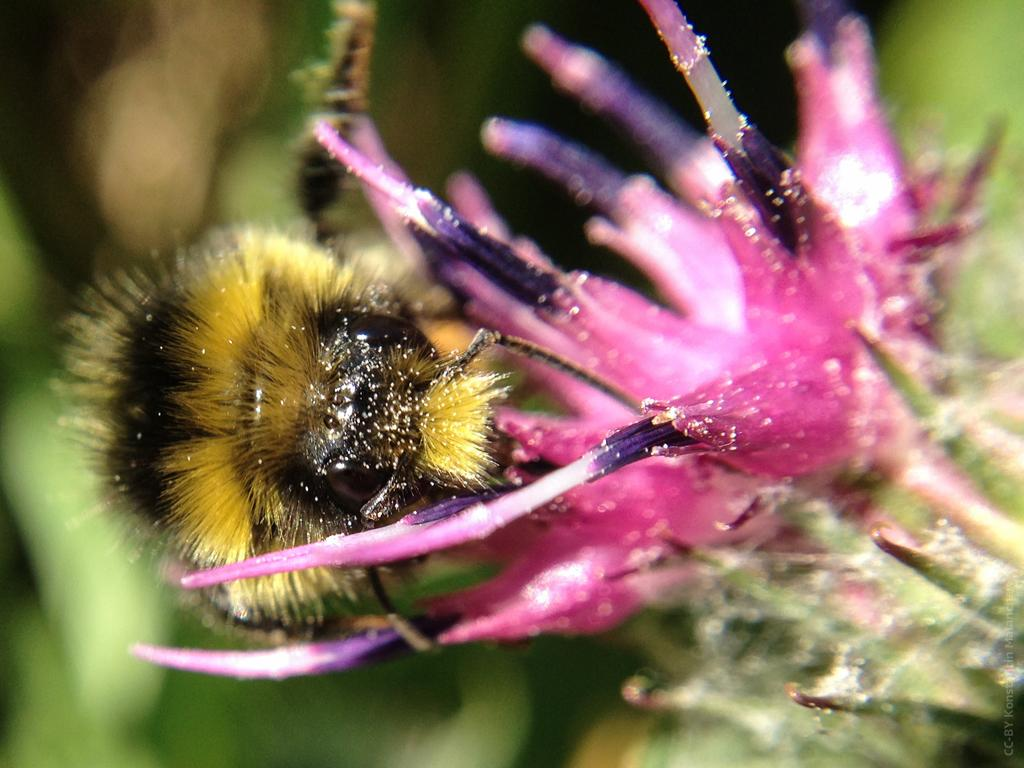What is the main subject in the foreground of the image? There is a flower in the foreground of the image. Is there anything interacting with the flower? Yes, there is a bee on the flower. What can be seen in the background of the image? There are plants in the background of the image. Can you see any quince trees near the seashore in the image? There is no mention of quince trees or a seashore in the image; it features a flower with a bee and plants in the background. 